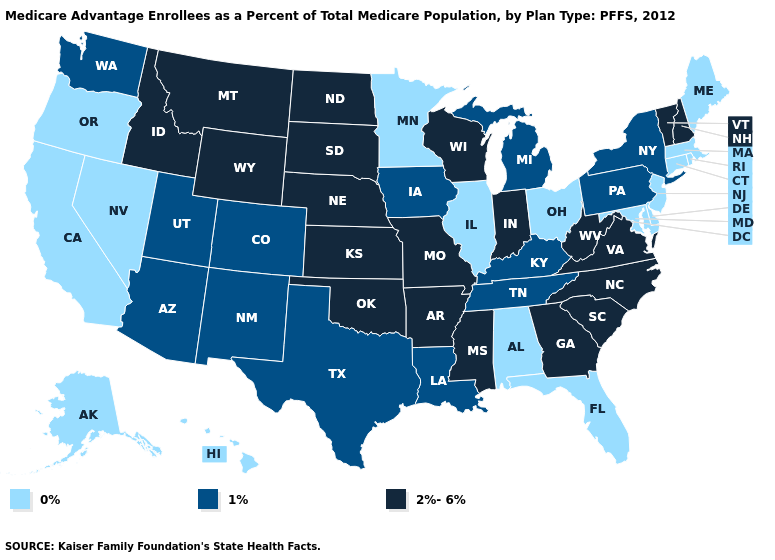Among the states that border New Hampshire , does Maine have the lowest value?
Keep it brief. Yes. Which states have the lowest value in the USA?
Quick response, please. Alaska, Alabama, California, Connecticut, Delaware, Florida, Hawaii, Illinois, Massachusetts, Maryland, Maine, Minnesota, New Jersey, Nevada, Ohio, Oregon, Rhode Island. What is the highest value in the South ?
Give a very brief answer. 2%-6%. What is the lowest value in the Northeast?
Short answer required. 0%. What is the value of Illinois?
Concise answer only. 0%. Name the states that have a value in the range 2%-6%?
Answer briefly. Arkansas, Georgia, Idaho, Indiana, Kansas, Missouri, Mississippi, Montana, North Carolina, North Dakota, Nebraska, New Hampshire, Oklahoma, South Carolina, South Dakota, Virginia, Vermont, Wisconsin, West Virginia, Wyoming. What is the value of Utah?
Give a very brief answer. 1%. What is the value of Georgia?
Quick response, please. 2%-6%. How many symbols are there in the legend?
Quick response, please. 3. Does California have the highest value in the West?
Be succinct. No. Does Louisiana have the same value as Arizona?
Answer briefly. Yes. Which states have the lowest value in the USA?
Concise answer only. Alaska, Alabama, California, Connecticut, Delaware, Florida, Hawaii, Illinois, Massachusetts, Maryland, Maine, Minnesota, New Jersey, Nevada, Ohio, Oregon, Rhode Island. Does the first symbol in the legend represent the smallest category?
Short answer required. Yes. What is the value of Illinois?
Give a very brief answer. 0%. 